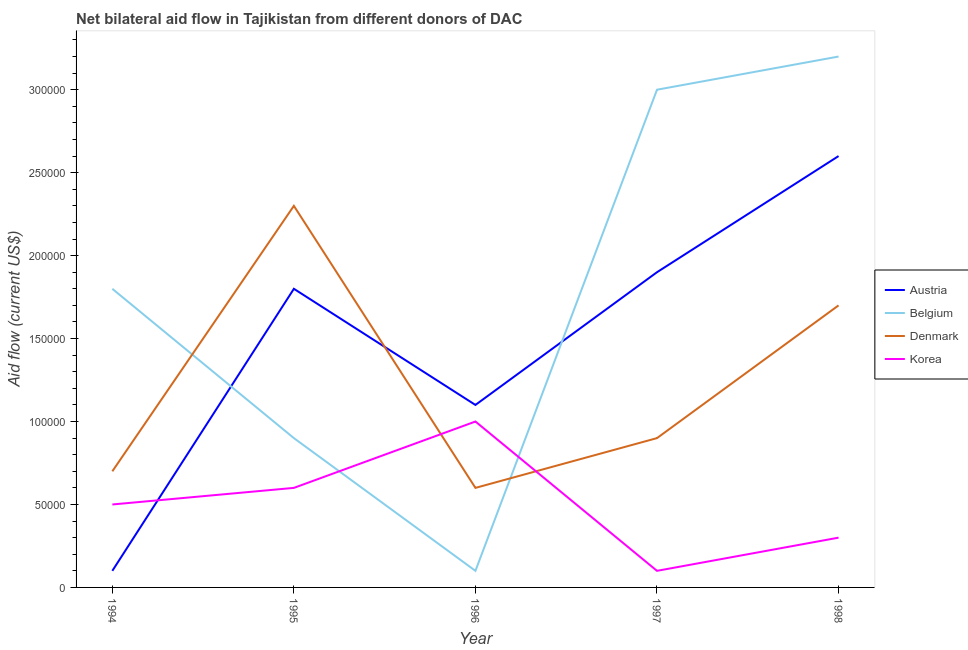How many different coloured lines are there?
Provide a succinct answer. 4. Does the line corresponding to amount of aid given by austria intersect with the line corresponding to amount of aid given by belgium?
Provide a short and direct response. Yes. What is the amount of aid given by belgium in 1996?
Your answer should be very brief. 10000. Across all years, what is the maximum amount of aid given by denmark?
Your response must be concise. 2.30e+05. Across all years, what is the minimum amount of aid given by austria?
Ensure brevity in your answer.  10000. In which year was the amount of aid given by belgium maximum?
Ensure brevity in your answer.  1998. What is the total amount of aid given by korea in the graph?
Your response must be concise. 2.50e+05. What is the difference between the amount of aid given by austria in 1997 and that in 1998?
Your answer should be compact. -7.00e+04. What is the difference between the amount of aid given by denmark in 1997 and the amount of aid given by belgium in 1996?
Keep it short and to the point. 8.00e+04. What is the average amount of aid given by austria per year?
Provide a succinct answer. 1.50e+05. In the year 1994, what is the difference between the amount of aid given by korea and amount of aid given by denmark?
Provide a succinct answer. -2.00e+04. In how many years, is the amount of aid given by denmark greater than 220000 US$?
Your answer should be very brief. 1. What is the ratio of the amount of aid given by denmark in 1995 to that in 1998?
Give a very brief answer. 1.35. Is the amount of aid given by belgium in 1995 less than that in 1996?
Keep it short and to the point. No. What is the difference between the highest and the second highest amount of aid given by belgium?
Your answer should be compact. 2.00e+04. What is the difference between the highest and the lowest amount of aid given by denmark?
Offer a very short reply. 1.70e+05. In how many years, is the amount of aid given by denmark greater than the average amount of aid given by denmark taken over all years?
Provide a short and direct response. 2. Is the sum of the amount of aid given by denmark in 1995 and 1997 greater than the maximum amount of aid given by korea across all years?
Offer a very short reply. Yes. Is it the case that in every year, the sum of the amount of aid given by denmark and amount of aid given by belgium is greater than the sum of amount of aid given by korea and amount of aid given by austria?
Offer a terse response. No. Is the amount of aid given by denmark strictly less than the amount of aid given by austria over the years?
Offer a very short reply. No. How many lines are there?
Offer a terse response. 4. Does the graph contain grids?
Your answer should be compact. No. Where does the legend appear in the graph?
Offer a terse response. Center right. What is the title of the graph?
Make the answer very short. Net bilateral aid flow in Tajikistan from different donors of DAC. Does "UNPBF" appear as one of the legend labels in the graph?
Your answer should be very brief. No. What is the label or title of the Y-axis?
Provide a short and direct response. Aid flow (current US$). What is the Aid flow (current US$) of Austria in 1994?
Offer a very short reply. 10000. What is the Aid flow (current US$) in Belgium in 1994?
Give a very brief answer. 1.80e+05. What is the Aid flow (current US$) of Austria in 1995?
Your answer should be very brief. 1.80e+05. What is the Aid flow (current US$) in Belgium in 1997?
Your answer should be compact. 3.00e+05. What is the Aid flow (current US$) of Denmark in 1997?
Provide a succinct answer. 9.00e+04. What is the Aid flow (current US$) of Belgium in 1998?
Your response must be concise. 3.20e+05. What is the Aid flow (current US$) in Korea in 1998?
Ensure brevity in your answer.  3.00e+04. Across all years, what is the maximum Aid flow (current US$) of Austria?
Your response must be concise. 2.60e+05. Across all years, what is the maximum Aid flow (current US$) of Denmark?
Your response must be concise. 2.30e+05. Across all years, what is the minimum Aid flow (current US$) in Austria?
Provide a short and direct response. 10000. Across all years, what is the minimum Aid flow (current US$) in Belgium?
Your answer should be compact. 10000. Across all years, what is the minimum Aid flow (current US$) in Korea?
Ensure brevity in your answer.  10000. What is the total Aid flow (current US$) of Austria in the graph?
Your response must be concise. 7.50e+05. What is the total Aid flow (current US$) in Denmark in the graph?
Your answer should be very brief. 6.20e+05. What is the total Aid flow (current US$) of Korea in the graph?
Your response must be concise. 2.50e+05. What is the difference between the Aid flow (current US$) in Korea in 1994 and that in 1995?
Offer a very short reply. -10000. What is the difference between the Aid flow (current US$) in Austria in 1994 and that in 1996?
Keep it short and to the point. -1.00e+05. What is the difference between the Aid flow (current US$) of Belgium in 1994 and that in 1996?
Provide a succinct answer. 1.70e+05. What is the difference between the Aid flow (current US$) of Korea in 1994 and that in 1996?
Keep it short and to the point. -5.00e+04. What is the difference between the Aid flow (current US$) of Austria in 1994 and that in 1997?
Make the answer very short. -1.80e+05. What is the difference between the Aid flow (current US$) in Denmark in 1994 and that in 1997?
Your answer should be compact. -2.00e+04. What is the difference between the Aid flow (current US$) in Korea in 1994 and that in 1998?
Offer a terse response. 2.00e+04. What is the difference between the Aid flow (current US$) in Austria in 1995 and that in 1996?
Ensure brevity in your answer.  7.00e+04. What is the difference between the Aid flow (current US$) in Denmark in 1995 and that in 1996?
Keep it short and to the point. 1.70e+05. What is the difference between the Aid flow (current US$) of Korea in 1995 and that in 1996?
Your response must be concise. -4.00e+04. What is the difference between the Aid flow (current US$) of Austria in 1995 and that in 1998?
Keep it short and to the point. -8.00e+04. What is the difference between the Aid flow (current US$) in Austria in 1996 and that in 1997?
Provide a succinct answer. -8.00e+04. What is the difference between the Aid flow (current US$) in Belgium in 1996 and that in 1997?
Your response must be concise. -2.90e+05. What is the difference between the Aid flow (current US$) of Denmark in 1996 and that in 1997?
Provide a succinct answer. -3.00e+04. What is the difference between the Aid flow (current US$) of Korea in 1996 and that in 1997?
Your response must be concise. 9.00e+04. What is the difference between the Aid flow (current US$) of Austria in 1996 and that in 1998?
Provide a short and direct response. -1.50e+05. What is the difference between the Aid flow (current US$) of Belgium in 1996 and that in 1998?
Your response must be concise. -3.10e+05. What is the difference between the Aid flow (current US$) of Korea in 1996 and that in 1998?
Provide a succinct answer. 7.00e+04. What is the difference between the Aid flow (current US$) in Austria in 1997 and that in 1998?
Make the answer very short. -7.00e+04. What is the difference between the Aid flow (current US$) of Belgium in 1997 and that in 1998?
Ensure brevity in your answer.  -2.00e+04. What is the difference between the Aid flow (current US$) in Austria in 1994 and the Aid flow (current US$) in Belgium in 1995?
Your answer should be very brief. -8.00e+04. What is the difference between the Aid flow (current US$) in Denmark in 1994 and the Aid flow (current US$) in Korea in 1995?
Provide a succinct answer. 10000. What is the difference between the Aid flow (current US$) in Austria in 1994 and the Aid flow (current US$) in Belgium in 1996?
Offer a terse response. 0. What is the difference between the Aid flow (current US$) in Austria in 1994 and the Aid flow (current US$) in Korea in 1996?
Your response must be concise. -9.00e+04. What is the difference between the Aid flow (current US$) in Denmark in 1994 and the Aid flow (current US$) in Korea in 1996?
Your answer should be very brief. -3.00e+04. What is the difference between the Aid flow (current US$) in Belgium in 1994 and the Aid flow (current US$) in Denmark in 1997?
Ensure brevity in your answer.  9.00e+04. What is the difference between the Aid flow (current US$) of Belgium in 1994 and the Aid flow (current US$) of Korea in 1997?
Your answer should be compact. 1.70e+05. What is the difference between the Aid flow (current US$) of Austria in 1994 and the Aid flow (current US$) of Belgium in 1998?
Make the answer very short. -3.10e+05. What is the difference between the Aid flow (current US$) of Belgium in 1994 and the Aid flow (current US$) of Denmark in 1998?
Keep it short and to the point. 10000. What is the difference between the Aid flow (current US$) of Denmark in 1994 and the Aid flow (current US$) of Korea in 1998?
Give a very brief answer. 4.00e+04. What is the difference between the Aid flow (current US$) in Denmark in 1995 and the Aid flow (current US$) in Korea in 1996?
Keep it short and to the point. 1.30e+05. What is the difference between the Aid flow (current US$) of Austria in 1995 and the Aid flow (current US$) of Belgium in 1997?
Ensure brevity in your answer.  -1.20e+05. What is the difference between the Aid flow (current US$) of Belgium in 1995 and the Aid flow (current US$) of Korea in 1997?
Provide a succinct answer. 8.00e+04. What is the difference between the Aid flow (current US$) in Austria in 1995 and the Aid flow (current US$) in Belgium in 1998?
Make the answer very short. -1.40e+05. What is the difference between the Aid flow (current US$) in Austria in 1995 and the Aid flow (current US$) in Denmark in 1998?
Keep it short and to the point. 10000. What is the difference between the Aid flow (current US$) of Austria in 1995 and the Aid flow (current US$) of Korea in 1998?
Your answer should be very brief. 1.50e+05. What is the difference between the Aid flow (current US$) of Belgium in 1996 and the Aid flow (current US$) of Denmark in 1997?
Keep it short and to the point. -8.00e+04. What is the difference between the Aid flow (current US$) in Denmark in 1996 and the Aid flow (current US$) in Korea in 1997?
Offer a terse response. 5.00e+04. What is the difference between the Aid flow (current US$) of Austria in 1996 and the Aid flow (current US$) of Belgium in 1998?
Offer a terse response. -2.10e+05. What is the difference between the Aid flow (current US$) of Austria in 1996 and the Aid flow (current US$) of Denmark in 1998?
Provide a succinct answer. -6.00e+04. What is the difference between the Aid flow (current US$) of Austria in 1996 and the Aid flow (current US$) of Korea in 1998?
Offer a very short reply. 8.00e+04. What is the difference between the Aid flow (current US$) of Belgium in 1996 and the Aid flow (current US$) of Denmark in 1998?
Provide a succinct answer. -1.60e+05. What is the difference between the Aid flow (current US$) in Belgium in 1996 and the Aid flow (current US$) in Korea in 1998?
Provide a succinct answer. -2.00e+04. What is the difference between the Aid flow (current US$) in Austria in 1997 and the Aid flow (current US$) in Korea in 1998?
Keep it short and to the point. 1.60e+05. What is the difference between the Aid flow (current US$) of Belgium in 1997 and the Aid flow (current US$) of Korea in 1998?
Provide a succinct answer. 2.70e+05. What is the difference between the Aid flow (current US$) of Denmark in 1997 and the Aid flow (current US$) of Korea in 1998?
Make the answer very short. 6.00e+04. What is the average Aid flow (current US$) in Denmark per year?
Offer a terse response. 1.24e+05. In the year 1994, what is the difference between the Aid flow (current US$) of Austria and Aid flow (current US$) of Denmark?
Keep it short and to the point. -6.00e+04. In the year 1994, what is the difference between the Aid flow (current US$) of Austria and Aid flow (current US$) of Korea?
Offer a terse response. -4.00e+04. In the year 1994, what is the difference between the Aid flow (current US$) of Denmark and Aid flow (current US$) of Korea?
Provide a short and direct response. 2.00e+04. In the year 1995, what is the difference between the Aid flow (current US$) in Austria and Aid flow (current US$) in Belgium?
Ensure brevity in your answer.  9.00e+04. In the year 1995, what is the difference between the Aid flow (current US$) in Austria and Aid flow (current US$) in Denmark?
Offer a very short reply. -5.00e+04. In the year 1995, what is the difference between the Aid flow (current US$) of Belgium and Aid flow (current US$) of Denmark?
Make the answer very short. -1.40e+05. In the year 1995, what is the difference between the Aid flow (current US$) in Denmark and Aid flow (current US$) in Korea?
Provide a succinct answer. 1.70e+05. In the year 1996, what is the difference between the Aid flow (current US$) of Austria and Aid flow (current US$) of Belgium?
Your answer should be very brief. 1.00e+05. In the year 1996, what is the difference between the Aid flow (current US$) of Belgium and Aid flow (current US$) of Denmark?
Offer a terse response. -5.00e+04. In the year 1996, what is the difference between the Aid flow (current US$) in Belgium and Aid flow (current US$) in Korea?
Ensure brevity in your answer.  -9.00e+04. In the year 1997, what is the difference between the Aid flow (current US$) of Austria and Aid flow (current US$) of Belgium?
Make the answer very short. -1.10e+05. In the year 1997, what is the difference between the Aid flow (current US$) in Belgium and Aid flow (current US$) in Denmark?
Offer a very short reply. 2.10e+05. In the year 1997, what is the difference between the Aid flow (current US$) of Belgium and Aid flow (current US$) of Korea?
Make the answer very short. 2.90e+05. In the year 1997, what is the difference between the Aid flow (current US$) of Denmark and Aid flow (current US$) of Korea?
Ensure brevity in your answer.  8.00e+04. In the year 1998, what is the difference between the Aid flow (current US$) of Austria and Aid flow (current US$) of Denmark?
Your answer should be compact. 9.00e+04. In the year 1998, what is the difference between the Aid flow (current US$) of Austria and Aid flow (current US$) of Korea?
Provide a short and direct response. 2.30e+05. In the year 1998, what is the difference between the Aid flow (current US$) in Belgium and Aid flow (current US$) in Denmark?
Keep it short and to the point. 1.50e+05. In the year 1998, what is the difference between the Aid flow (current US$) in Belgium and Aid flow (current US$) in Korea?
Your answer should be compact. 2.90e+05. What is the ratio of the Aid flow (current US$) of Austria in 1994 to that in 1995?
Provide a succinct answer. 0.06. What is the ratio of the Aid flow (current US$) of Belgium in 1994 to that in 1995?
Your answer should be compact. 2. What is the ratio of the Aid flow (current US$) in Denmark in 1994 to that in 1995?
Offer a terse response. 0.3. What is the ratio of the Aid flow (current US$) of Korea in 1994 to that in 1995?
Make the answer very short. 0.83. What is the ratio of the Aid flow (current US$) in Austria in 1994 to that in 1996?
Offer a terse response. 0.09. What is the ratio of the Aid flow (current US$) in Belgium in 1994 to that in 1996?
Your answer should be compact. 18. What is the ratio of the Aid flow (current US$) in Denmark in 1994 to that in 1996?
Offer a terse response. 1.17. What is the ratio of the Aid flow (current US$) in Austria in 1994 to that in 1997?
Ensure brevity in your answer.  0.05. What is the ratio of the Aid flow (current US$) of Korea in 1994 to that in 1997?
Offer a very short reply. 5. What is the ratio of the Aid flow (current US$) in Austria in 1994 to that in 1998?
Your answer should be compact. 0.04. What is the ratio of the Aid flow (current US$) of Belgium in 1994 to that in 1998?
Your answer should be compact. 0.56. What is the ratio of the Aid flow (current US$) in Denmark in 1994 to that in 1998?
Your response must be concise. 0.41. What is the ratio of the Aid flow (current US$) of Korea in 1994 to that in 1998?
Offer a terse response. 1.67. What is the ratio of the Aid flow (current US$) of Austria in 1995 to that in 1996?
Keep it short and to the point. 1.64. What is the ratio of the Aid flow (current US$) of Belgium in 1995 to that in 1996?
Offer a terse response. 9. What is the ratio of the Aid flow (current US$) in Denmark in 1995 to that in 1996?
Your response must be concise. 3.83. What is the ratio of the Aid flow (current US$) of Korea in 1995 to that in 1996?
Your response must be concise. 0.6. What is the ratio of the Aid flow (current US$) of Belgium in 1995 to that in 1997?
Your response must be concise. 0.3. What is the ratio of the Aid flow (current US$) in Denmark in 1995 to that in 1997?
Your response must be concise. 2.56. What is the ratio of the Aid flow (current US$) of Korea in 1995 to that in 1997?
Your response must be concise. 6. What is the ratio of the Aid flow (current US$) of Austria in 1995 to that in 1998?
Provide a succinct answer. 0.69. What is the ratio of the Aid flow (current US$) of Belgium in 1995 to that in 1998?
Provide a succinct answer. 0.28. What is the ratio of the Aid flow (current US$) in Denmark in 1995 to that in 1998?
Keep it short and to the point. 1.35. What is the ratio of the Aid flow (current US$) of Korea in 1995 to that in 1998?
Provide a short and direct response. 2. What is the ratio of the Aid flow (current US$) in Austria in 1996 to that in 1997?
Keep it short and to the point. 0.58. What is the ratio of the Aid flow (current US$) of Austria in 1996 to that in 1998?
Your answer should be very brief. 0.42. What is the ratio of the Aid flow (current US$) in Belgium in 1996 to that in 1998?
Offer a very short reply. 0.03. What is the ratio of the Aid flow (current US$) of Denmark in 1996 to that in 1998?
Your answer should be very brief. 0.35. What is the ratio of the Aid flow (current US$) of Austria in 1997 to that in 1998?
Provide a succinct answer. 0.73. What is the ratio of the Aid flow (current US$) of Denmark in 1997 to that in 1998?
Your answer should be very brief. 0.53. What is the difference between the highest and the second highest Aid flow (current US$) in Denmark?
Offer a terse response. 6.00e+04. What is the difference between the highest and the lowest Aid flow (current US$) of Austria?
Your answer should be compact. 2.50e+05. What is the difference between the highest and the lowest Aid flow (current US$) of Belgium?
Make the answer very short. 3.10e+05. What is the difference between the highest and the lowest Aid flow (current US$) of Denmark?
Your response must be concise. 1.70e+05. 